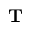Convert formula to latex. <formula><loc_0><loc_0><loc_500><loc_500>T</formula> 